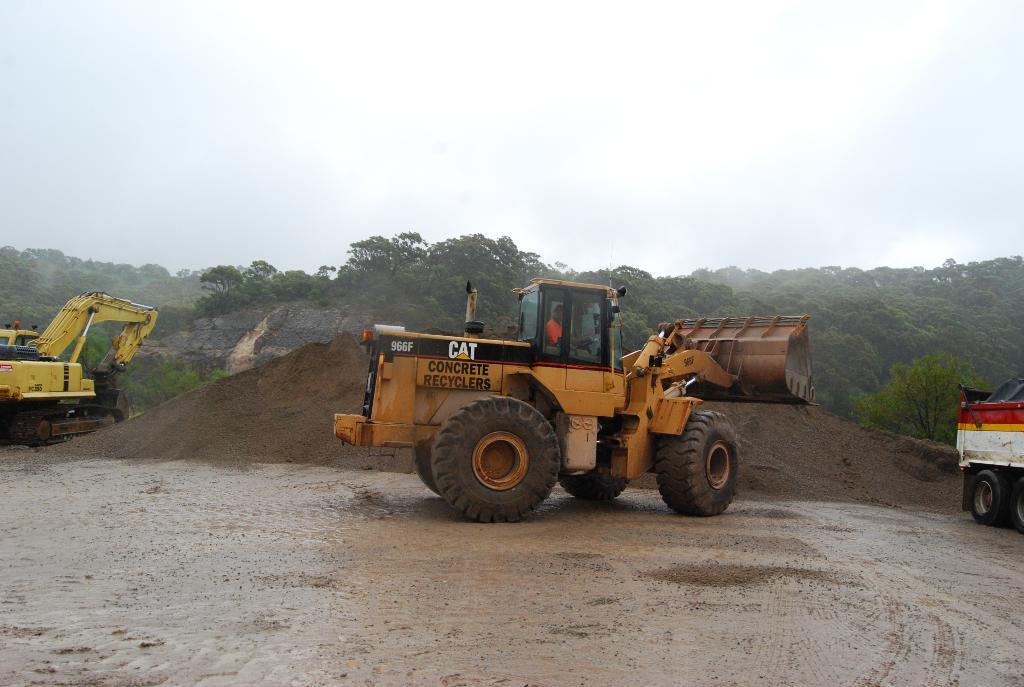Could you give a brief overview of what you see in this image? In this image we can see two bulldozers and a truck here. Here we can see the muddy water, sand, trees and the sky in the background. 